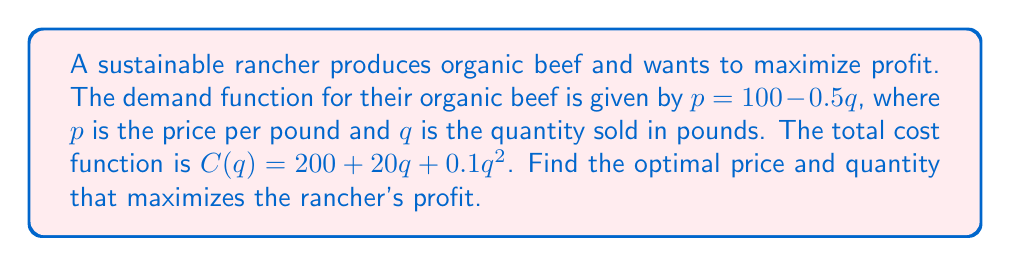Could you help me with this problem? 1. The profit function is given by:
   $$\Pi(q) = R(q) - C(q)$$
   where $R(q)$ is the revenue function and $C(q)$ is the cost function.

2. Revenue function:
   $$R(q) = pq = (100 - 0.5q)q = 100q - 0.5q^2$$

3. Profit function:
   $$\Pi(q) = (100q - 0.5q^2) - (200 + 20q + 0.1q^2)$$
   $$\Pi(q) = 100q - 0.5q^2 - 200 - 20q - 0.1q^2$$
   $$\Pi(q) = -0.6q^2 + 80q - 200$$

4. To maximize profit, find the derivative and set it equal to zero:
   $$\frac{d\Pi}{dq} = -1.2q + 80 = 0$$

5. Solve for q:
   $$-1.2q = -80$$
   $$q = \frac{80}{1.2} \approx 66.67$$

6. Round to the nearest whole number:
   $$q = 67$$

7. Calculate the optimal price using the demand function:
   $$p = 100 - 0.5(67) = 66.5$$

8. Round to the nearest cent:
   $$p = $66.50$$
Answer: Optimal quantity: 67 pounds; Optimal price: $66.50 per pound 